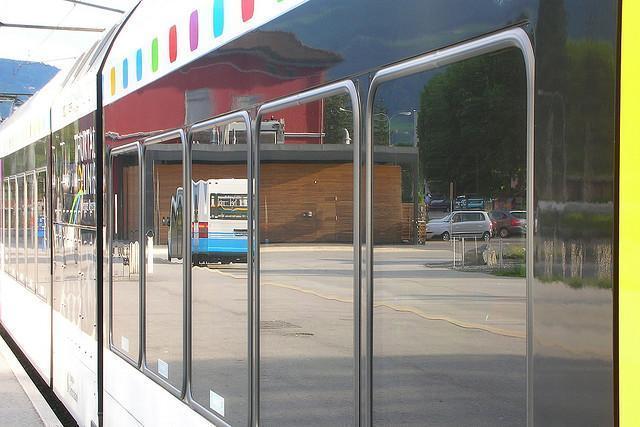How many red chairs are there?
Give a very brief answer. 0. 